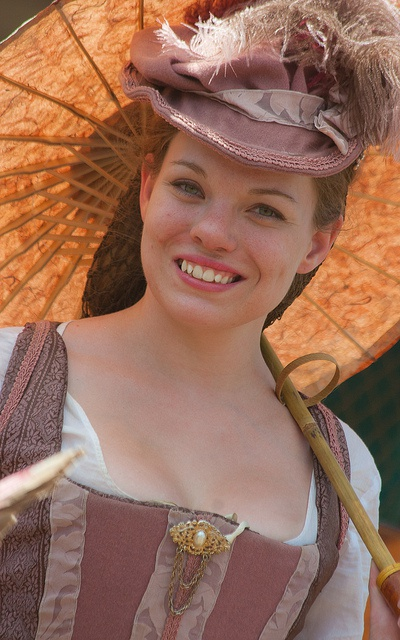Describe the objects in this image and their specific colors. I can see people in maroon, gray, brown, and darkgray tones and umbrella in maroon, tan, brown, and red tones in this image. 